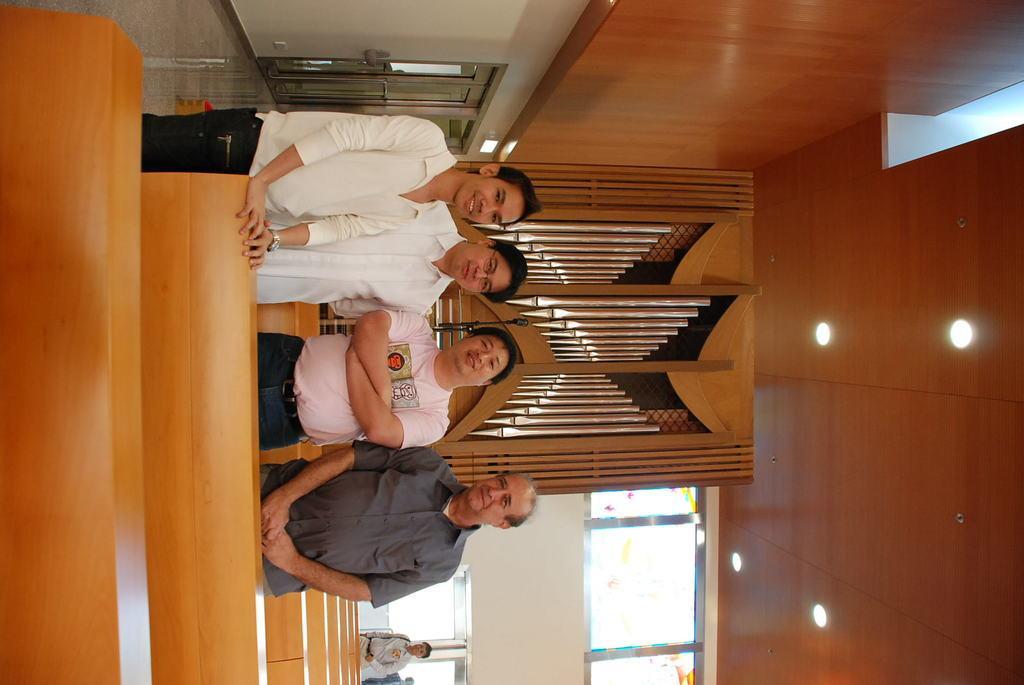In one or two sentences, can you explain what this image depicts? In the image we can see there are people standing on the ground and there are benches. Behind there is another person standing and there are lightings on the top. 